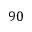Convert formula to latex. <formula><loc_0><loc_0><loc_500><loc_500>9 0</formula> 